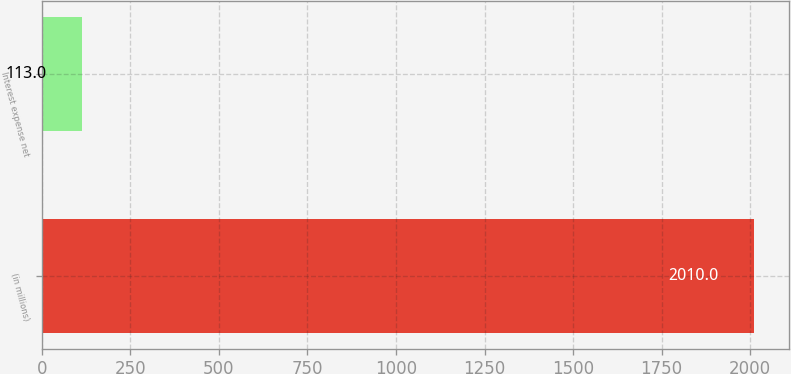Convert chart. <chart><loc_0><loc_0><loc_500><loc_500><bar_chart><fcel>(in millions)<fcel>Interest expense net<nl><fcel>2010<fcel>113<nl></chart> 